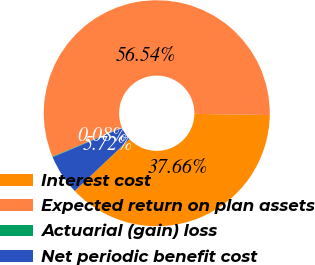<chart> <loc_0><loc_0><loc_500><loc_500><pie_chart><fcel>Interest cost<fcel>Expected return on plan assets<fcel>Actuarial (gain) loss<fcel>Net periodic benefit cost<nl><fcel>37.66%<fcel>56.53%<fcel>0.08%<fcel>5.72%<nl></chart> 